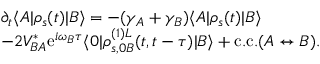Convert formula to latex. <formula><loc_0><loc_0><loc_500><loc_500>\begin{array} { r l } & { \partial _ { t } \langle A | \rho _ { s } ( t ) | B \rangle = - ( \gamma _ { A } + \gamma _ { B } ) \langle A | \rho _ { s } ( t ) | B \rangle } \\ & { - 2 V _ { B A } ^ { * } e ^ { i \omega _ { B } \tau } \langle 0 | \rho _ { s , 0 B } ^ { ( 1 ) L } ( t , t - \tau ) | B \rangle + c . c . ( A \leftrightarrow B ) . } \end{array}</formula> 